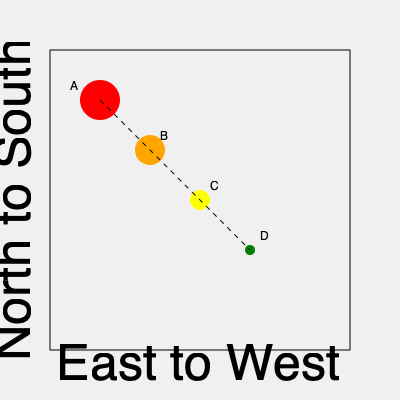Based on the map of Washington state showing wildfire spread patterns, which direction are the fires most likely moving, and what factor might be contributing to this pattern? To answer this question, let's analyze the map step-by-step:

1. Observe the circles: The map shows four circles labeled A, B, C, and D.

2. Interpret the circles:
   - Circle A (red) is the largest and positioned in the northwest.
   - Circle B (orange) is slightly smaller and southeast of A.
   - Circle C (yellow) is even smaller and southeast of B.
   - Circle D (green) is the smallest and furthest southeast.

3. Understand the axes:
   - The x-axis represents East to West direction.
   - The y-axis represents North to South direction.

4. Analyze the pattern:
   - The circles decrease in size from northwest to southeast.
   - This suggests the fire is spreading from northwest to southeast.

5. Consider contributing factors:
   - In Washington state, prevailing winds often blow from the northwest to the southeast.
   - Wind is a significant factor in wildfire spread.

6. Draw a conclusion:
   - The fires are most likely moving from northwest to southeast.
   - The prevailing winds in Washington are likely contributing to this spread pattern.

This analysis aligns with a firefighter's understanding of wildfire behavior and local environmental conditions in Washington state.
Answer: Northwest to Southeast; prevailing winds 